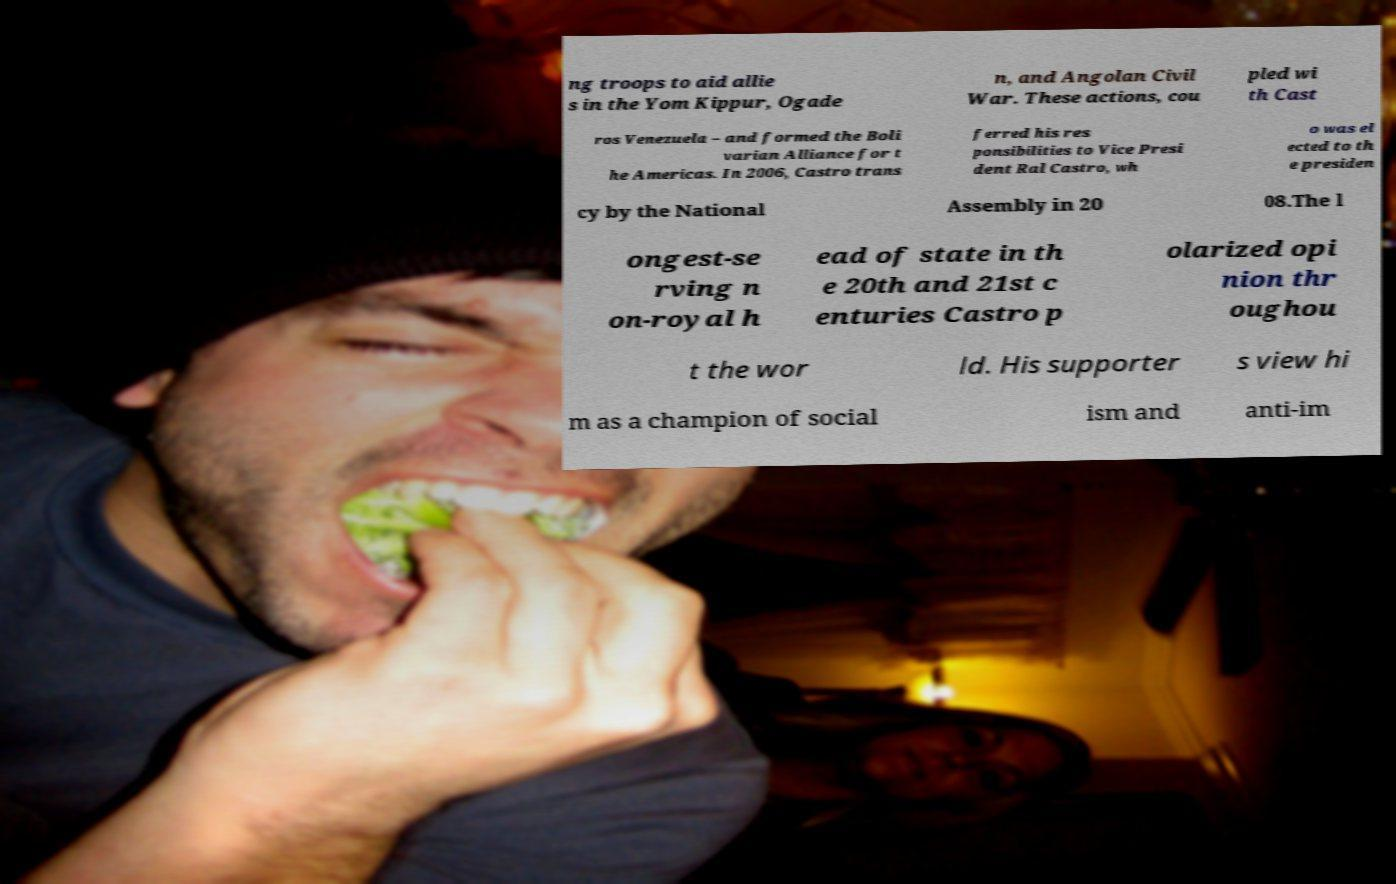Please read and relay the text visible in this image. What does it say? ng troops to aid allie s in the Yom Kippur, Ogade n, and Angolan Civil War. These actions, cou pled wi th Cast ros Venezuela – and formed the Boli varian Alliance for t he Americas. In 2006, Castro trans ferred his res ponsibilities to Vice Presi dent Ral Castro, wh o was el ected to th e presiden cy by the National Assembly in 20 08.The l ongest-se rving n on-royal h ead of state in th e 20th and 21st c enturies Castro p olarized opi nion thr oughou t the wor ld. His supporter s view hi m as a champion of social ism and anti-im 